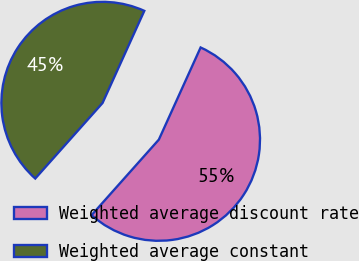Convert chart. <chart><loc_0><loc_0><loc_500><loc_500><pie_chart><fcel>Weighted average discount rate<fcel>Weighted average constant<nl><fcel>54.81%<fcel>45.19%<nl></chart> 